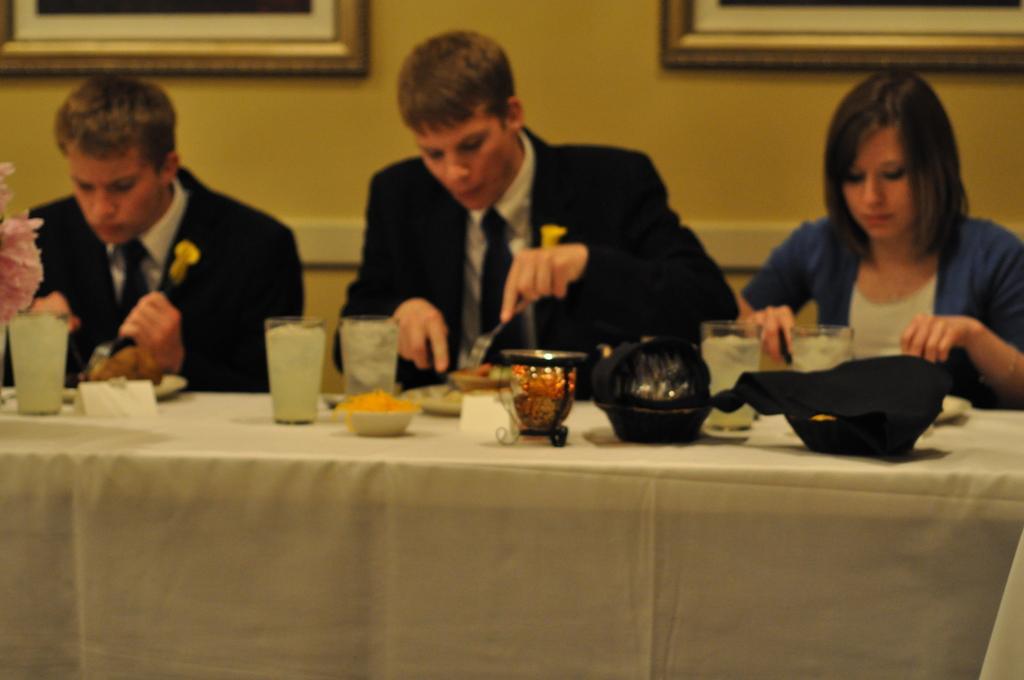Please provide a concise description of this image. In the picture there are two men wore suit and a woman wore shrug sat in front of table having food. There is a hat,bowl,cups,flower vase on the table and on the background there are two photo frames on the wall. 